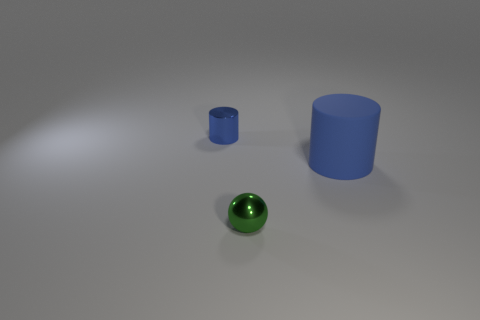Are there an equal number of big blue cylinders that are on the right side of the green ball and big matte cylinders to the left of the big blue matte cylinder?
Make the answer very short. No. There is a tiny object that is to the left of the tiny green thing; are there any blue shiny objects that are in front of it?
Keep it short and to the point. No. The green thing that is made of the same material as the small cylinder is what shape?
Your answer should be compact. Sphere. Is there anything else of the same color as the rubber thing?
Provide a succinct answer. Yes. There is a tiny thing that is in front of the cylinder that is left of the big cylinder; what is it made of?
Your response must be concise. Metal. Are there any tiny yellow objects that have the same shape as the large matte object?
Provide a succinct answer. No. How many other objects are there of the same shape as the tiny green thing?
Your answer should be compact. 0. What shape is the object that is both to the right of the tiny cylinder and to the left of the large blue matte cylinder?
Provide a short and direct response. Sphere. How big is the metallic thing that is in front of the large blue cylinder?
Give a very brief answer. Small. Is the blue shiny cylinder the same size as the ball?
Keep it short and to the point. Yes. 